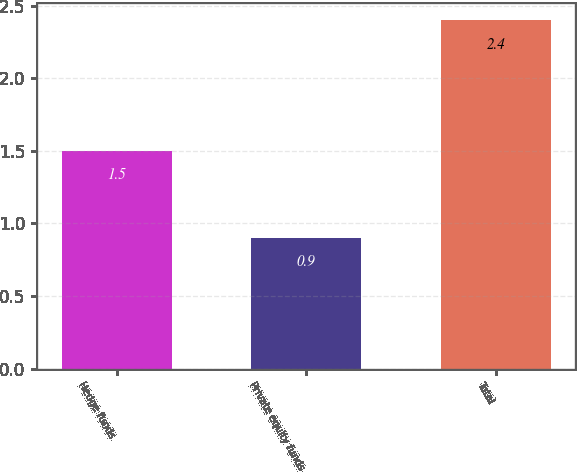Convert chart to OTSL. <chart><loc_0><loc_0><loc_500><loc_500><bar_chart><fcel>Hedge funds<fcel>Private equity funds<fcel>Total<nl><fcel>1.5<fcel>0.9<fcel>2.4<nl></chart> 